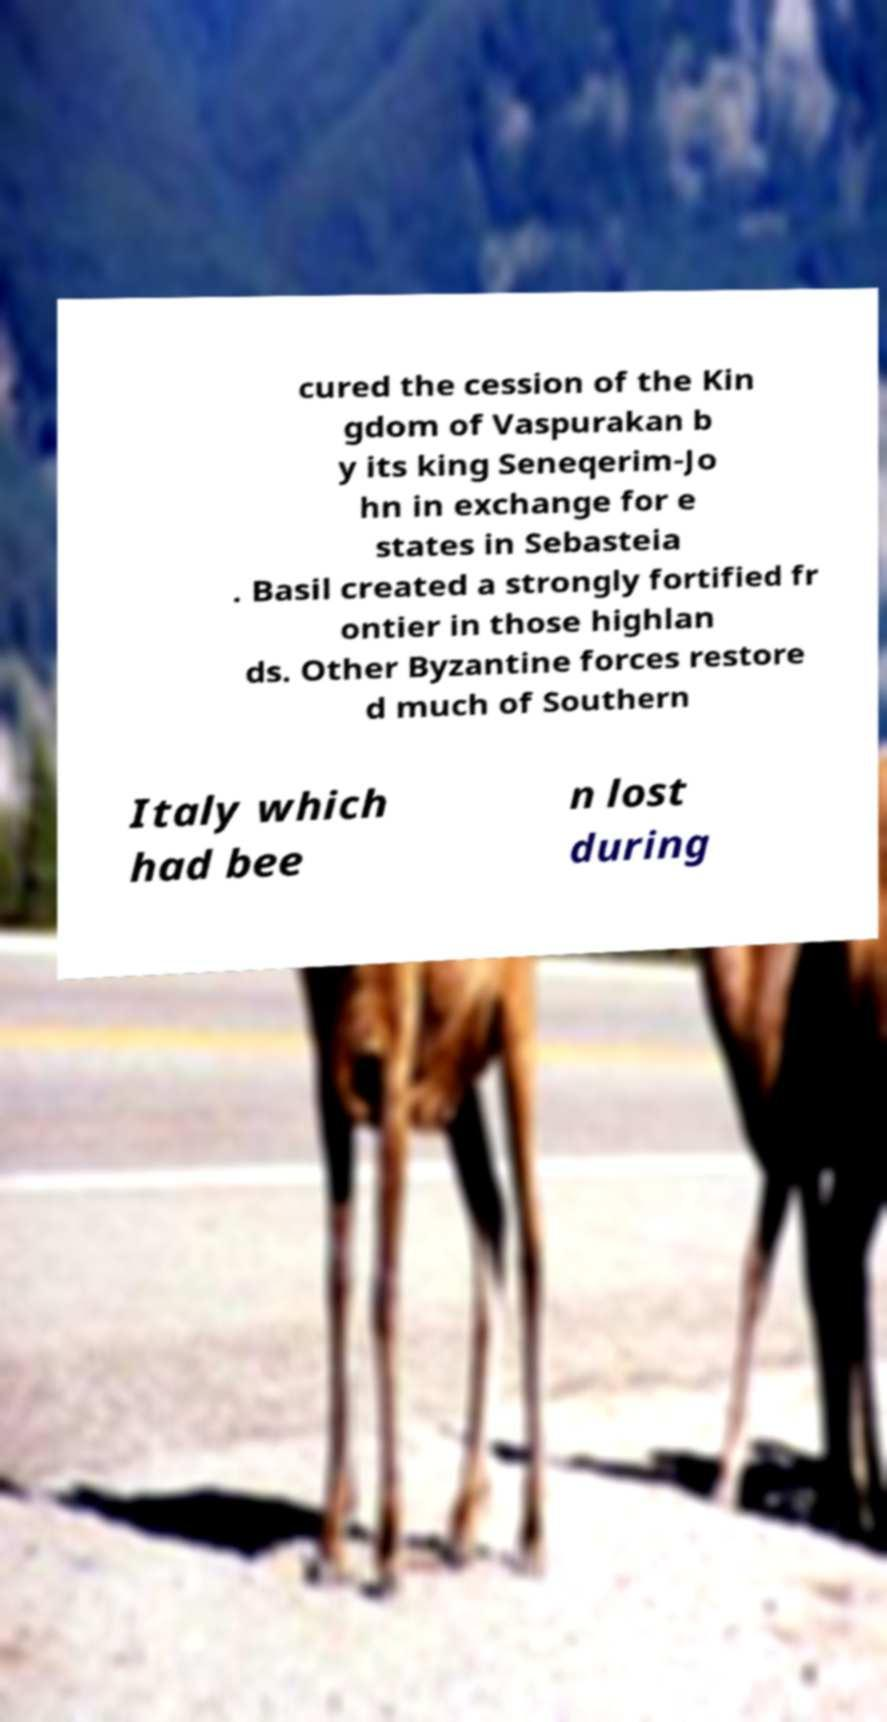I need the written content from this picture converted into text. Can you do that? cured the cession of the Kin gdom of Vaspurakan b y its king Seneqerim-Jo hn in exchange for e states in Sebasteia . Basil created a strongly fortified fr ontier in those highlan ds. Other Byzantine forces restore d much of Southern Italy which had bee n lost during 